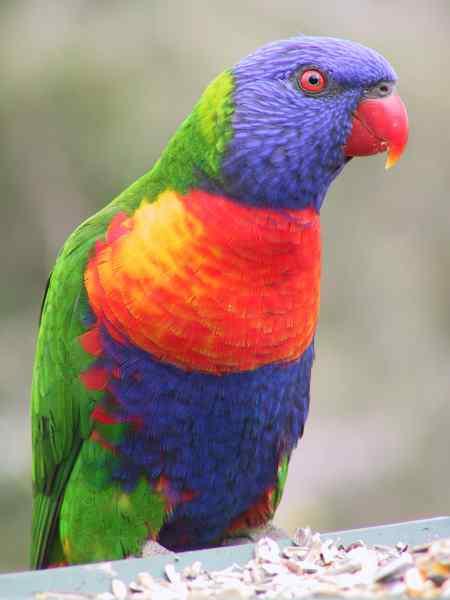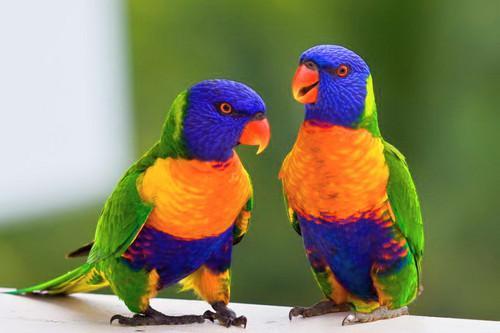The first image is the image on the left, the second image is the image on the right. Considering the images on both sides, is "There are two birds in the image on the right." valid? Answer yes or no. Yes. The first image is the image on the left, the second image is the image on the right. Evaluate the accuracy of this statement regarding the images: "At least one bird is facing towards the right side of the image.". Is it true? Answer yes or no. Yes. 